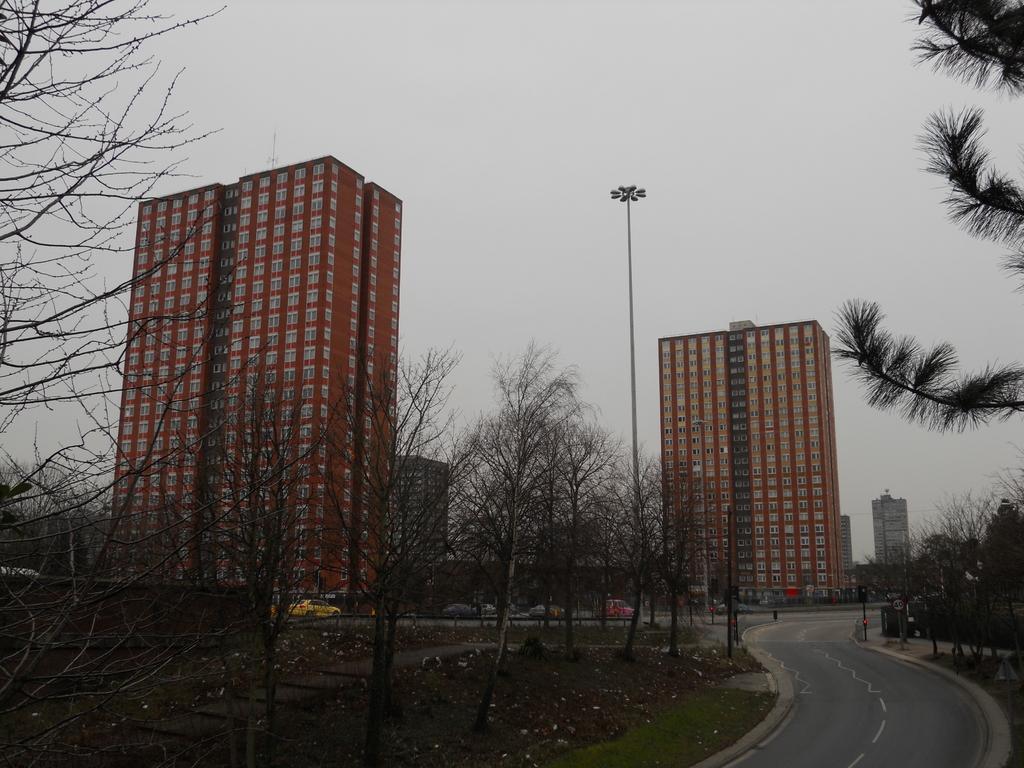Please provide a concise description of this image. In the background of the image there are buildings. There is a electric pole. In the center of the image there is a road. There are trees. At the top of the image there is sky. There is grass. 